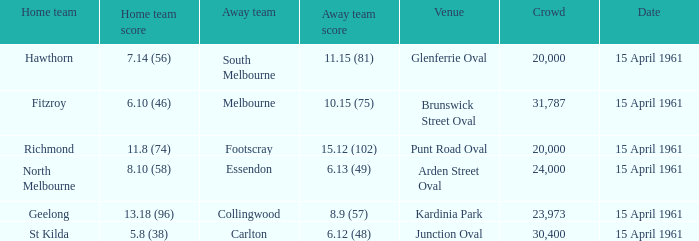Which place had a home team score of Brunswick Street Oval. Can you give me this table as a dict? {'header': ['Home team', 'Home team score', 'Away team', 'Away team score', 'Venue', 'Crowd', 'Date'], 'rows': [['Hawthorn', '7.14 (56)', 'South Melbourne', '11.15 (81)', 'Glenferrie Oval', '20,000', '15 April 1961'], ['Fitzroy', '6.10 (46)', 'Melbourne', '10.15 (75)', 'Brunswick Street Oval', '31,787', '15 April 1961'], ['Richmond', '11.8 (74)', 'Footscray', '15.12 (102)', 'Punt Road Oval', '20,000', '15 April 1961'], ['North Melbourne', '8.10 (58)', 'Essendon', '6.13 (49)', 'Arden Street Oval', '24,000', '15 April 1961'], ['Geelong', '13.18 (96)', 'Collingwood', '8.9 (57)', 'Kardinia Park', '23,973', '15 April 1961'], ['St Kilda', '5.8 (38)', 'Carlton', '6.12 (48)', 'Junction Oval', '30,400', '15 April 1961']]} 